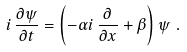<formula> <loc_0><loc_0><loc_500><loc_500>i \, \frac { \partial \psi } { \partial t } = \left ( - \alpha i \, \frac { \partial } { \partial x } + \beta \right ) \psi \ .</formula> 